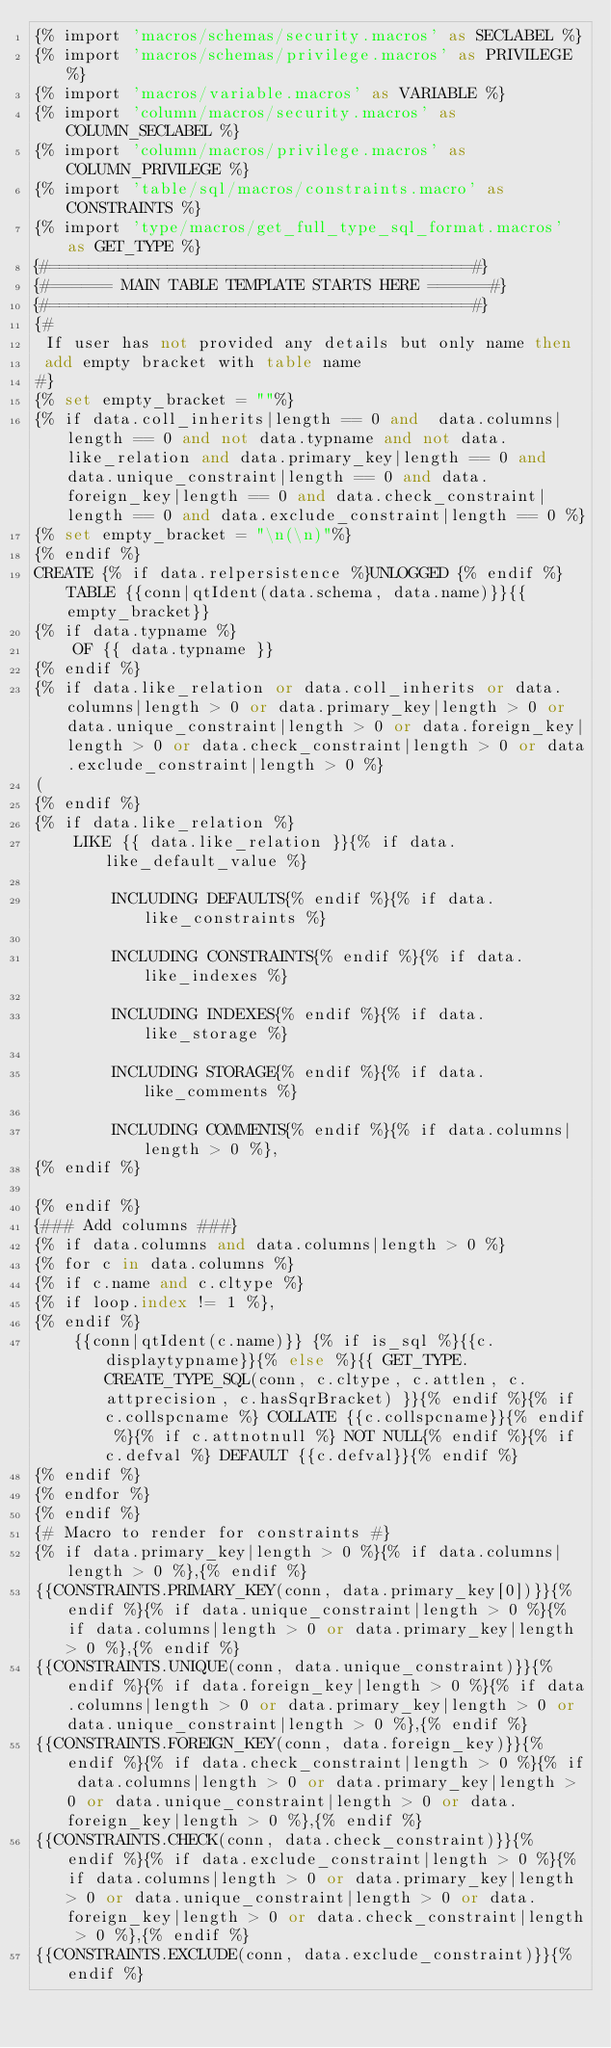<code> <loc_0><loc_0><loc_500><loc_500><_SQL_>{% import 'macros/schemas/security.macros' as SECLABEL %}
{% import 'macros/schemas/privilege.macros' as PRIVILEGE %}
{% import 'macros/variable.macros' as VARIABLE %}
{% import 'column/macros/security.macros' as COLUMN_SECLABEL %}
{% import 'column/macros/privilege.macros' as COLUMN_PRIVILEGE %}
{% import 'table/sql/macros/constraints.macro' as CONSTRAINTS %}
{% import 'type/macros/get_full_type_sql_format.macros' as GET_TYPE %}
{#===========================================#}
{#====== MAIN TABLE TEMPLATE STARTS HERE ======#}
{#===========================================#}
{#
 If user has not provided any details but only name then
 add empty bracket with table name
#}
{% set empty_bracket = ""%}
{% if data.coll_inherits|length == 0 and  data.columns|length == 0 and not data.typname and not data.like_relation and data.primary_key|length == 0 and data.unique_constraint|length == 0 and data.foreign_key|length == 0 and data.check_constraint|length == 0 and data.exclude_constraint|length == 0 %}
{% set empty_bracket = "\n(\n)"%}
{% endif %}
CREATE {% if data.relpersistence %}UNLOGGED {% endif %}TABLE {{conn|qtIdent(data.schema, data.name)}}{{empty_bracket}}
{% if data.typname %}
    OF {{ data.typname }}
{% endif %}
{% if data.like_relation or data.coll_inherits or data.columns|length > 0 or data.primary_key|length > 0 or data.unique_constraint|length > 0 or data.foreign_key|length > 0 or data.check_constraint|length > 0 or data.exclude_constraint|length > 0 %}
(
{% endif %}
{% if data.like_relation %}
    LIKE {{ data.like_relation }}{% if data.like_default_value %}

        INCLUDING DEFAULTS{% endif %}{% if data.like_constraints %}

        INCLUDING CONSTRAINTS{% endif %}{% if data.like_indexes %}

        INCLUDING INDEXES{% endif %}{% if data.like_storage %}

        INCLUDING STORAGE{% endif %}{% if data.like_comments %}

        INCLUDING COMMENTS{% endif %}{% if data.columns|length > 0 %},
{% endif %}

{% endif %}
{### Add columns ###}
{% if data.columns and data.columns|length > 0 %}
{% for c in data.columns %}
{% if c.name and c.cltype %}
{% if loop.index != 1 %},
{% endif %}
    {{conn|qtIdent(c.name)}} {% if is_sql %}{{c.displaytypname}}{% else %}{{ GET_TYPE.CREATE_TYPE_SQL(conn, c.cltype, c.attlen, c.attprecision, c.hasSqrBracket) }}{% endif %}{% if c.collspcname %} COLLATE {{c.collspcname}}{% endif %}{% if c.attnotnull %} NOT NULL{% endif %}{% if c.defval %} DEFAULT {{c.defval}}{% endif %}
{% endif %}
{% endfor %}
{% endif %}
{# Macro to render for constraints #}
{% if data.primary_key|length > 0 %}{% if data.columns|length > 0 %},{% endif %}
{{CONSTRAINTS.PRIMARY_KEY(conn, data.primary_key[0])}}{% endif %}{% if data.unique_constraint|length > 0 %}{% if data.columns|length > 0 or data.primary_key|length > 0 %},{% endif %}
{{CONSTRAINTS.UNIQUE(conn, data.unique_constraint)}}{% endif %}{% if data.foreign_key|length > 0 %}{% if data.columns|length > 0 or data.primary_key|length > 0 or data.unique_constraint|length > 0 %},{% endif %}
{{CONSTRAINTS.FOREIGN_KEY(conn, data.foreign_key)}}{% endif %}{% if data.check_constraint|length > 0 %}{% if data.columns|length > 0 or data.primary_key|length > 0 or data.unique_constraint|length > 0 or data.foreign_key|length > 0 %},{% endif %}
{{CONSTRAINTS.CHECK(conn, data.check_constraint)}}{% endif %}{% if data.exclude_constraint|length > 0 %}{% if data.columns|length > 0 or data.primary_key|length > 0 or data.unique_constraint|length > 0 or data.foreign_key|length > 0 or data.check_constraint|length > 0 %},{% endif %}
{{CONSTRAINTS.EXCLUDE(conn, data.exclude_constraint)}}{% endif %}</code> 